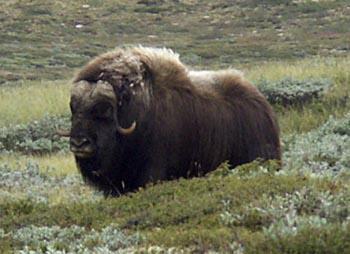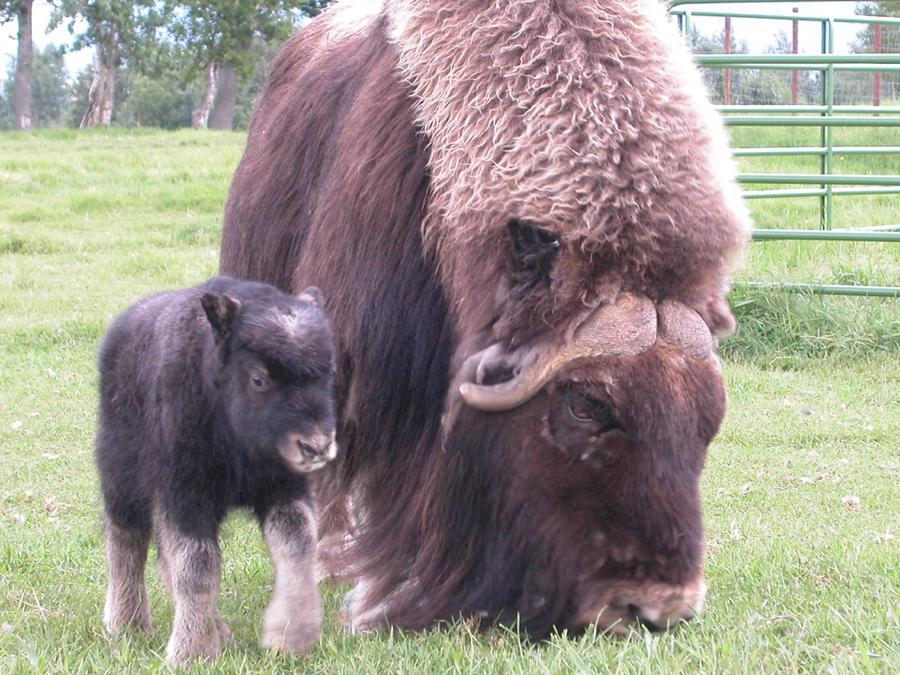The first image is the image on the left, the second image is the image on the right. Examine the images to the left and right. Is the description "There are trees in the background of the image on the left." accurate? Answer yes or no. No. 